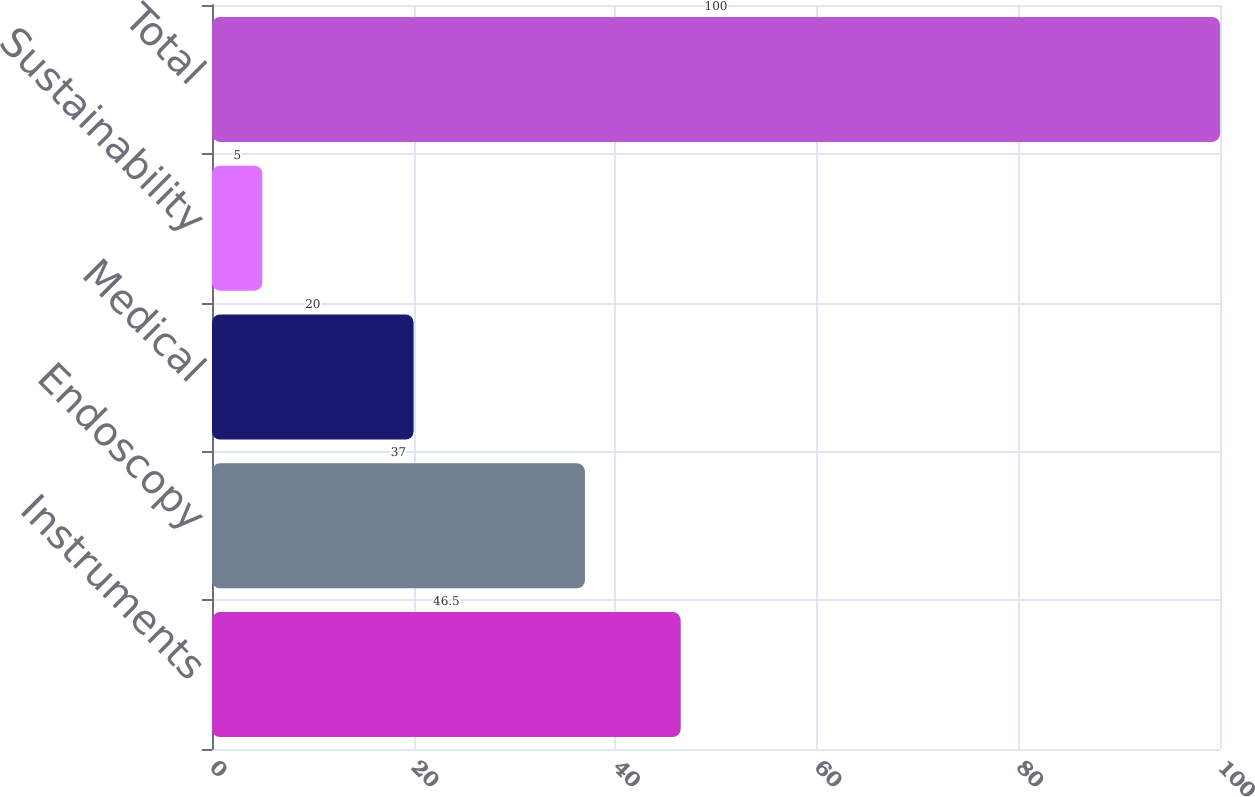Convert chart to OTSL. <chart><loc_0><loc_0><loc_500><loc_500><bar_chart><fcel>Instruments<fcel>Endoscopy<fcel>Medical<fcel>Sustainability<fcel>Total<nl><fcel>46.5<fcel>37<fcel>20<fcel>5<fcel>100<nl></chart> 